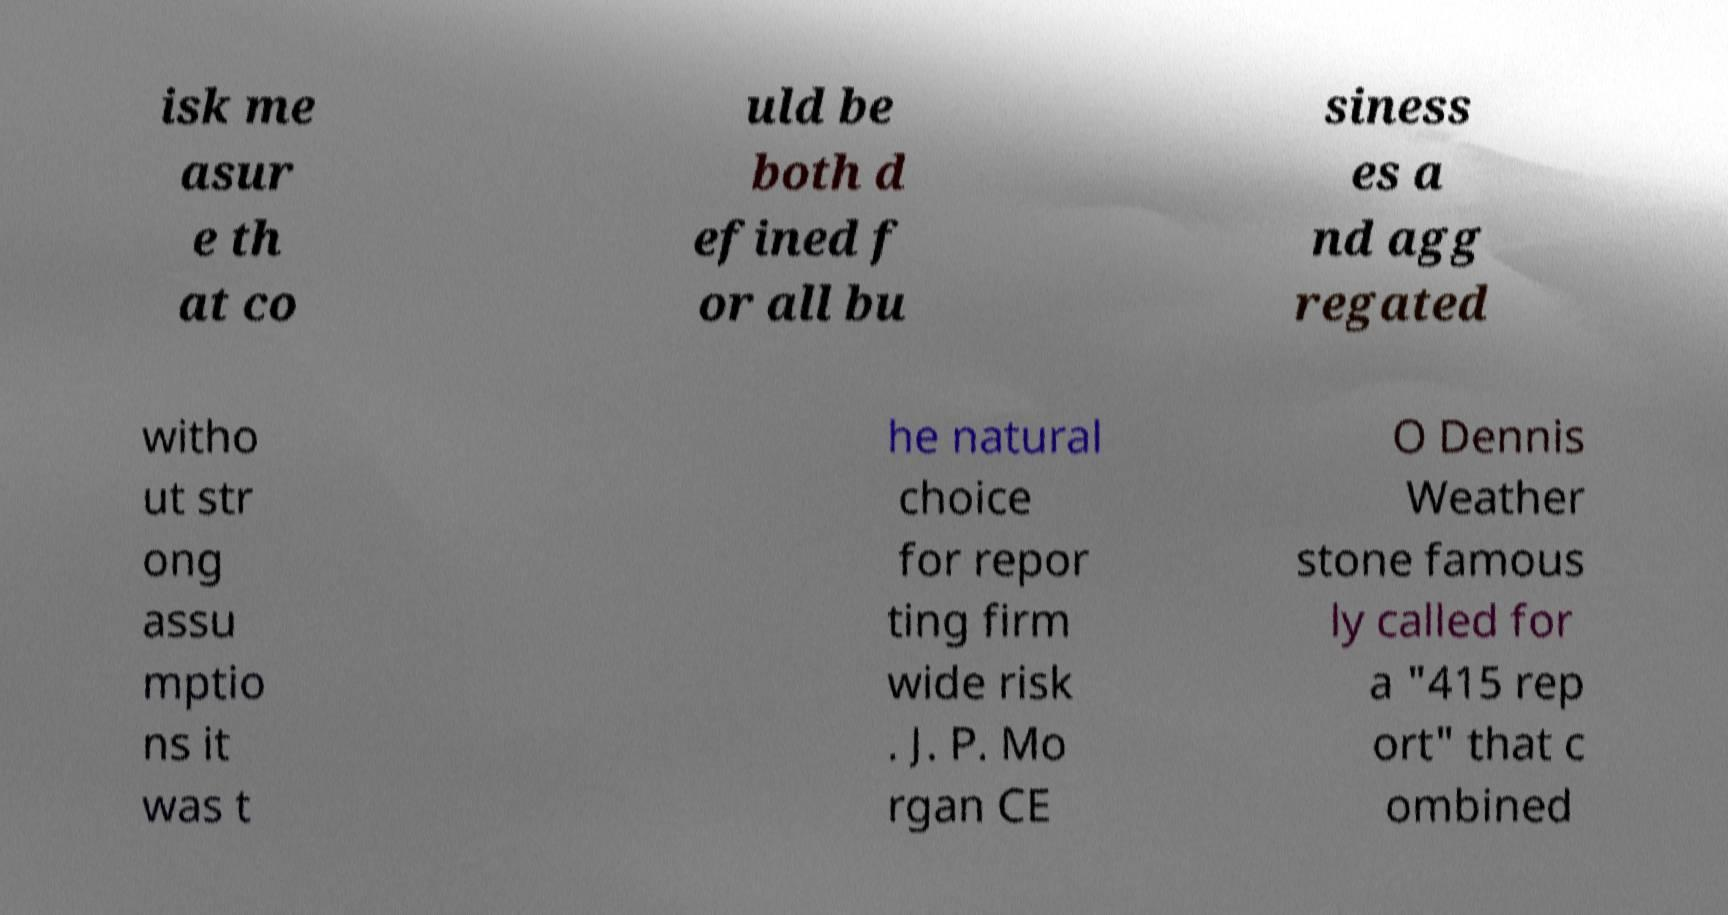Can you read and provide the text displayed in the image?This photo seems to have some interesting text. Can you extract and type it out for me? isk me asur e th at co uld be both d efined f or all bu siness es a nd agg regated witho ut str ong assu mptio ns it was t he natural choice for repor ting firm wide risk . J. P. Mo rgan CE O Dennis Weather stone famous ly called for a "415 rep ort" that c ombined 